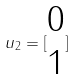Convert formula to latex. <formula><loc_0><loc_0><loc_500><loc_500>u _ { 2 } = [ \begin{matrix} 0 \\ 1 \end{matrix} ]</formula> 